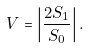Convert formula to latex. <formula><loc_0><loc_0><loc_500><loc_500>\ V = \left | \frac { 2 S _ { 1 } } { S _ { 0 } } \right | .</formula> 